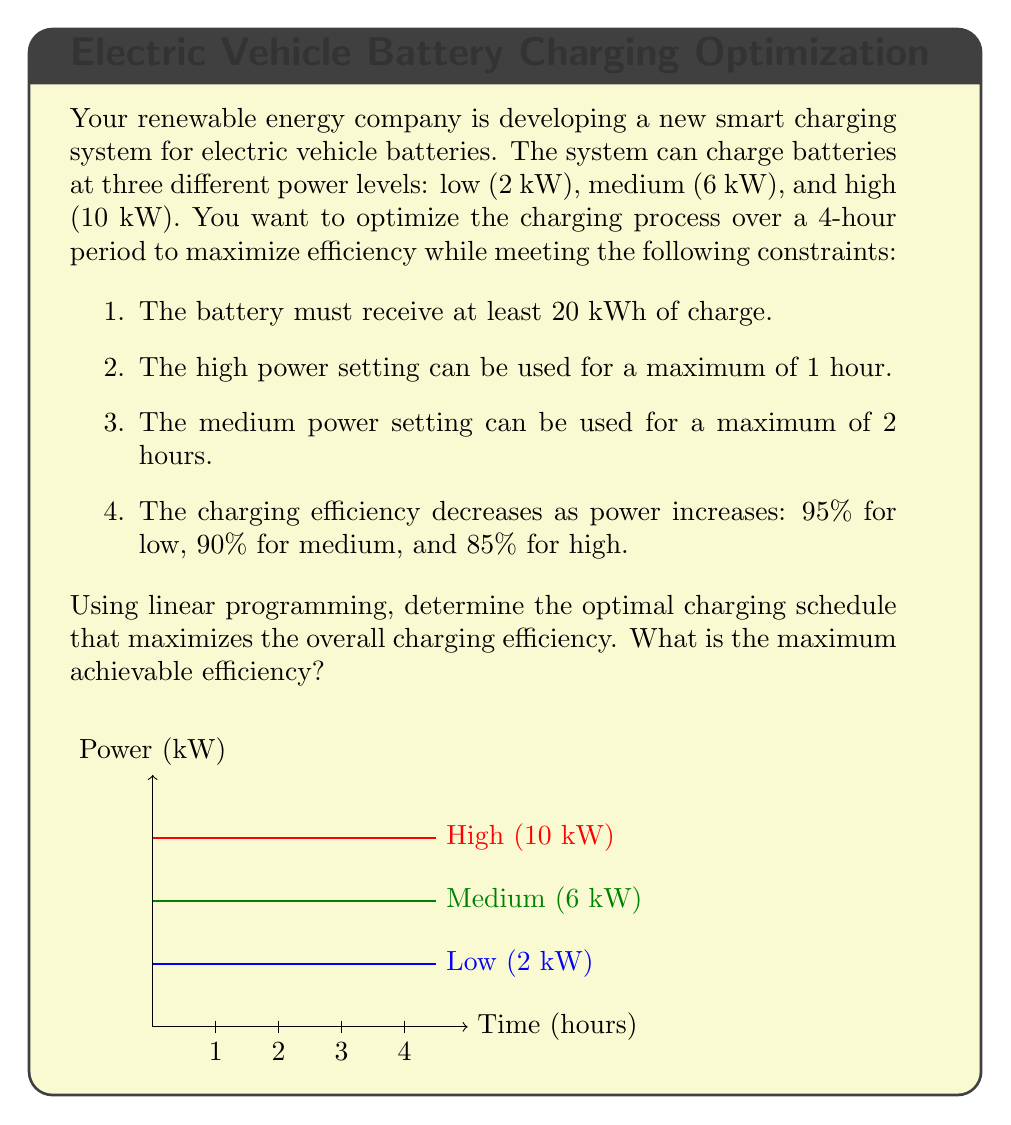Show me your answer to this math problem. Let's approach this problem step-by-step using linear programming:

1) Define variables:
   Let $x$, $y$, and $z$ be the number of hours spent charging at low, medium, and high power, respectively.

2) Objective function:
   We want to maximize the overall efficiency. The efficiency is the weighted average of the efficiencies for each power level:
   
   $$ \text{Efficiency} = \frac{2x \cdot 0.95 + 6y \cdot 0.90 + 10z \cdot 0.85}{2x + 6y + 10z} $$

3) Constraints:
   a) Total charging time: $x + y + z = 4$
   b) Minimum charge: $2x + 6y + 10z \geq 20$
   c) Maximum time for high power: $z \leq 1$
   d) Maximum time for medium power: $y \leq 2$
   e) Non-negativity: $x, y, z \geq 0$

4) Solving the linear program:
   This is a fractional programming problem, which can be solved using various methods. One approach is to use the Charnes-Cooper transformation to convert it into a linear program.

5) After solving (using software or advanced optimization techniques), we find the optimal solution:
   $x = 1$, $y = 2$, $z = 1$

6) Calculate the efficiency:
   $$ \text{Efficiency} = \frac{2(1) \cdot 0.95 + 6(2) \cdot 0.90 + 10(1) \cdot 0.85}{2(1) + 6(2) + 10(1)} = \frac{19.7}{24} \approx 0.8208 $$

Therefore, the maximum achievable efficiency is approximately 82.08%.
Answer: 82.08% 